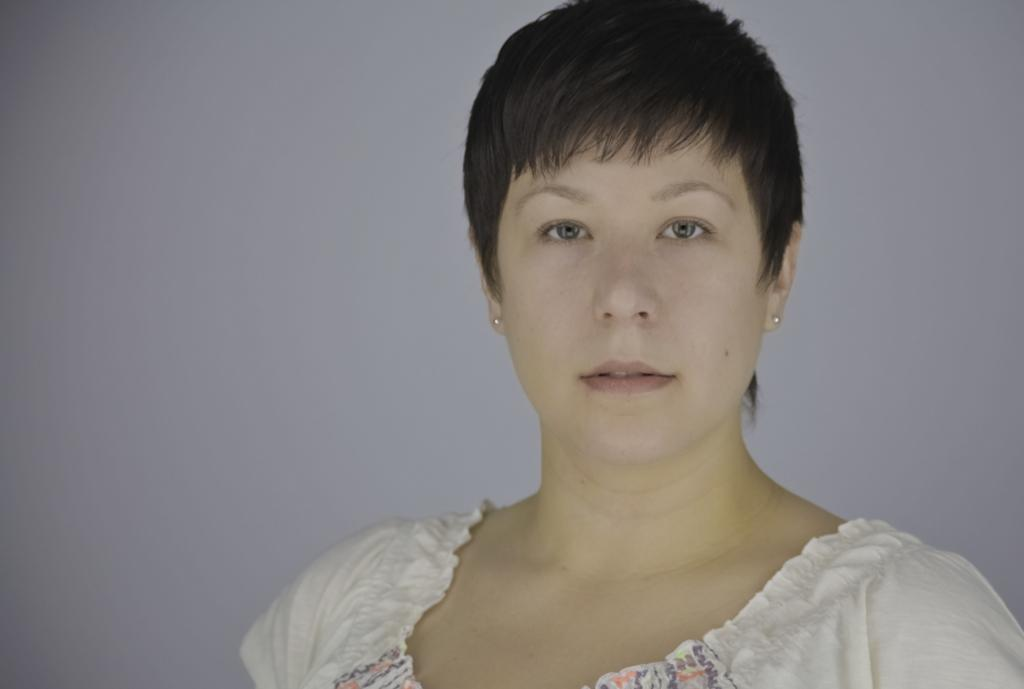Who is present in the image? There is a woman in the image. What is the woman wearing? The woman is wearing a white dress. What color can be seen in the background of the image? There is a gray color in the background of the image. How many cacti are visible in the image? There are no cacti present in the image. What type of blade is the woman holding in the image? The woman is not holding any blade in the image. 